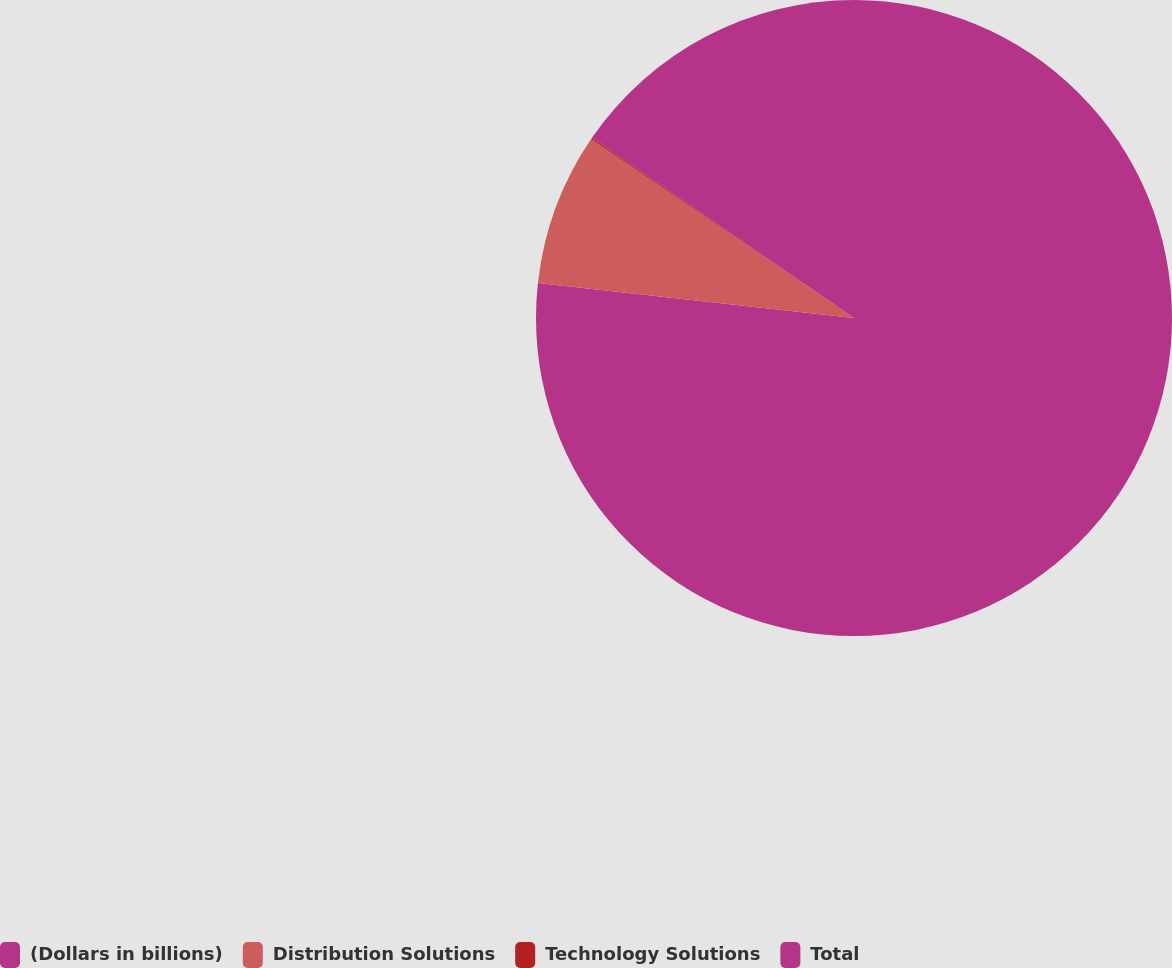<chart> <loc_0><loc_0><loc_500><loc_500><pie_chart><fcel>(Dollars in billions)<fcel>Distribution Solutions<fcel>Technology Solutions<fcel>Total<nl><fcel>76.76%<fcel>7.75%<fcel>0.08%<fcel>15.41%<nl></chart> 